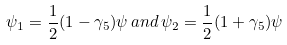<formula> <loc_0><loc_0><loc_500><loc_500>\psi _ { 1 } = \frac { 1 } { 2 } ( 1 - \gamma _ { 5 } ) \psi \, a n d \, \psi _ { 2 } = \frac { 1 } { 2 } ( 1 + \gamma _ { 5 } ) \psi</formula> 